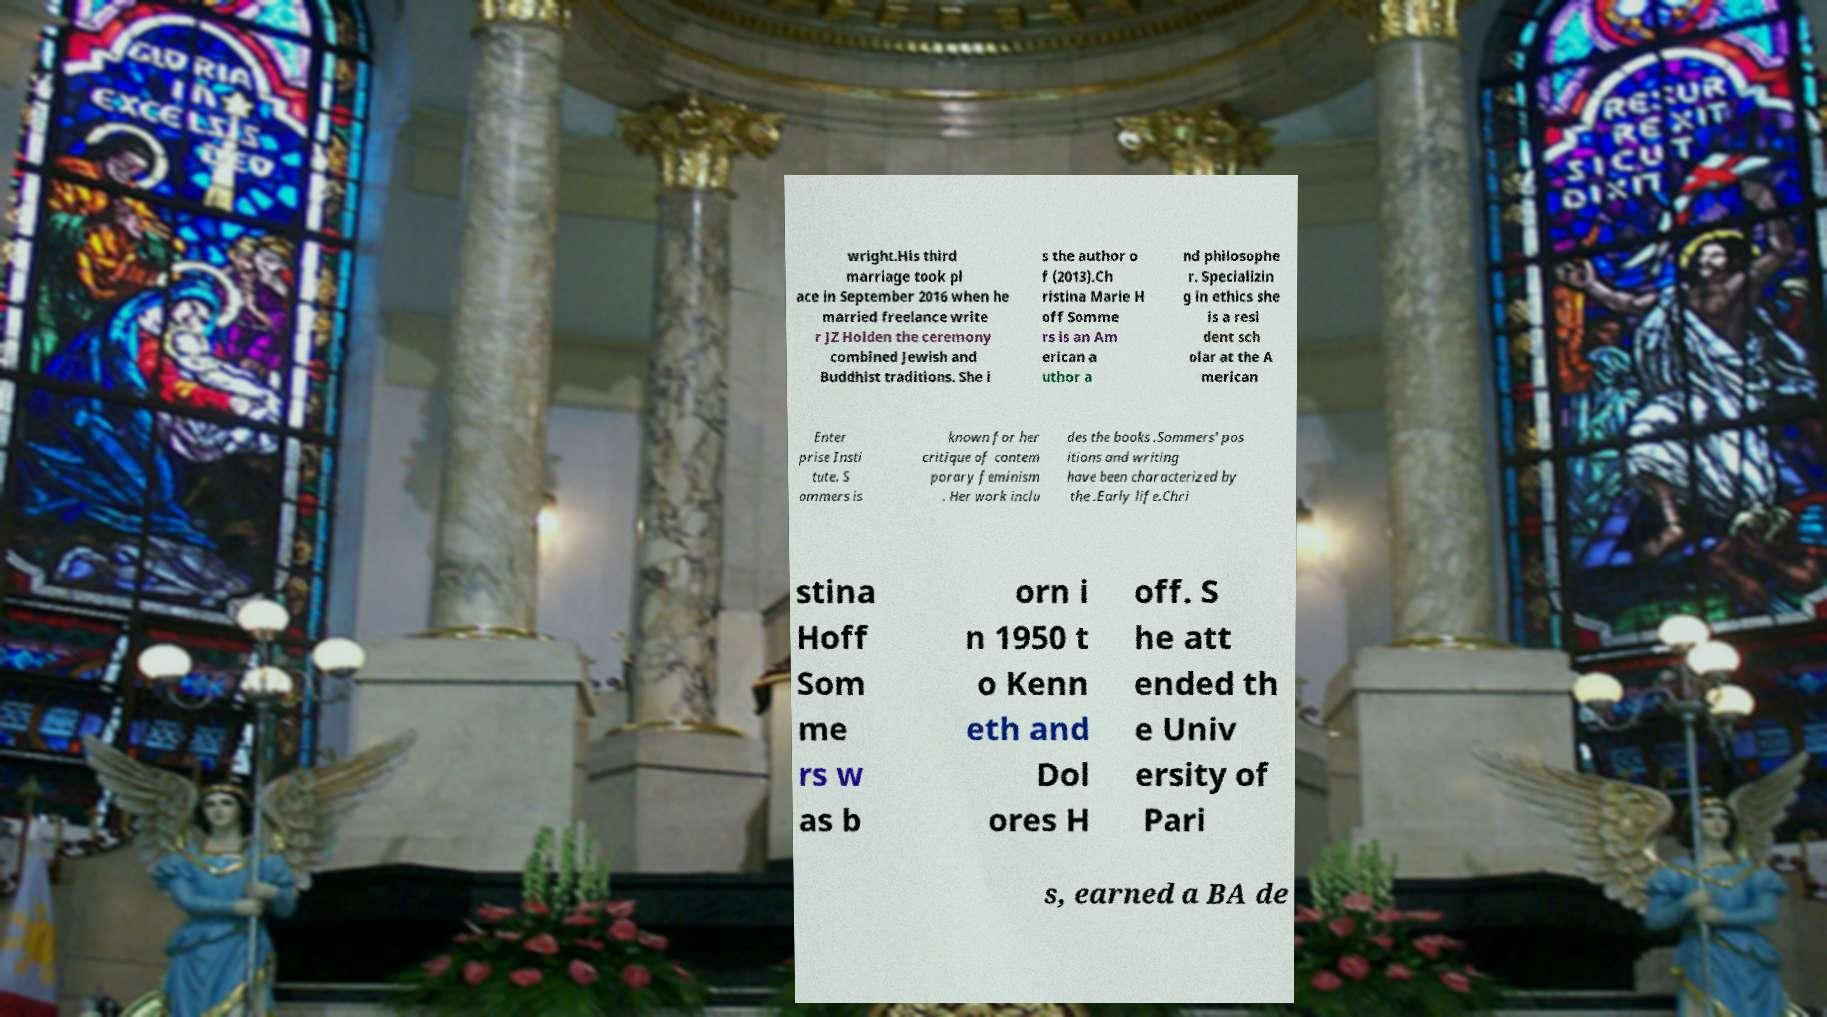What messages or text are displayed in this image? I need them in a readable, typed format. wright.His third marriage took pl ace in September 2016 when he married freelance write r JZ Holden the ceremony combined Jewish and Buddhist traditions. She i s the author o f (2013).Ch ristina Marie H off Somme rs is an Am erican a uthor a nd philosophe r. Specializin g in ethics she is a resi dent sch olar at the A merican Enter prise Insti tute. S ommers is known for her critique of contem porary feminism . Her work inclu des the books .Sommers' pos itions and writing have been characterized by the .Early life.Chri stina Hoff Som me rs w as b orn i n 1950 t o Kenn eth and Dol ores H off. S he att ended th e Univ ersity of Pari s, earned a BA de 